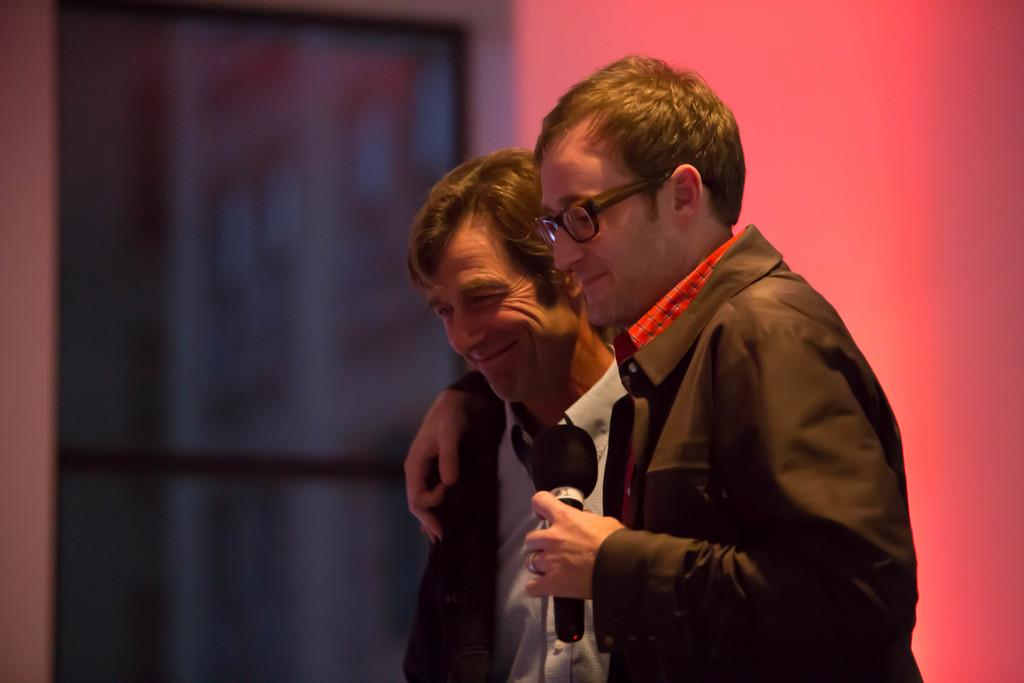How many people are in the image? There are two persons standing in the image. What is one of the persons holding? One of the persons is holding a mic. What can be seen in the background of the image? There is a wall in the background of the image. Can you see a cat playing with a power cord in the image? There is no cat or power cord present in the image. 